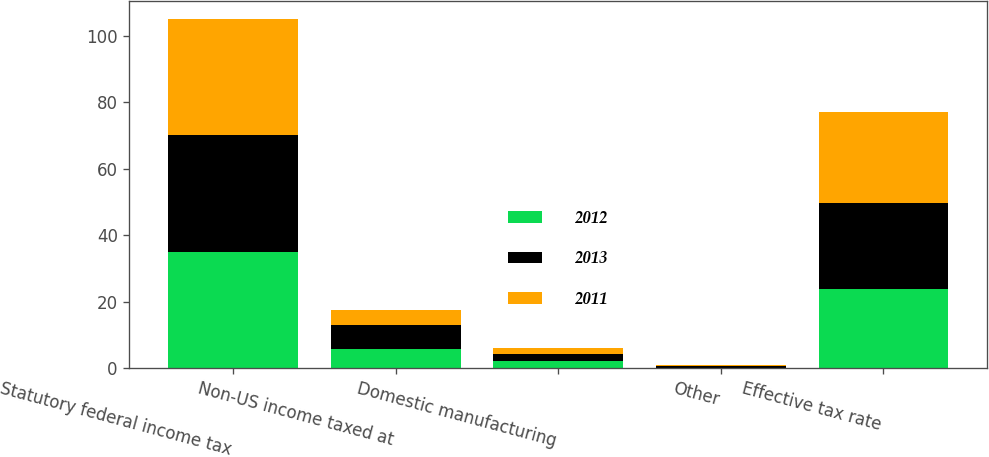<chart> <loc_0><loc_0><loc_500><loc_500><stacked_bar_chart><ecel><fcel>Statutory federal income tax<fcel>Non-US income taxed at<fcel>Domestic manufacturing<fcel>Other<fcel>Effective tax rate<nl><fcel>2012<fcel>35<fcel>5.8<fcel>2.1<fcel>0.1<fcel>23.7<nl><fcel>2013<fcel>35<fcel>7.3<fcel>2.1<fcel>0.4<fcel>26<nl><fcel>2011<fcel>35<fcel>4.4<fcel>1.9<fcel>0.5<fcel>27.2<nl></chart> 